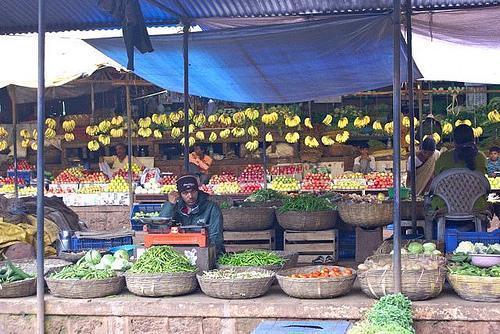How many people can be seen?
Give a very brief answer. 2. 